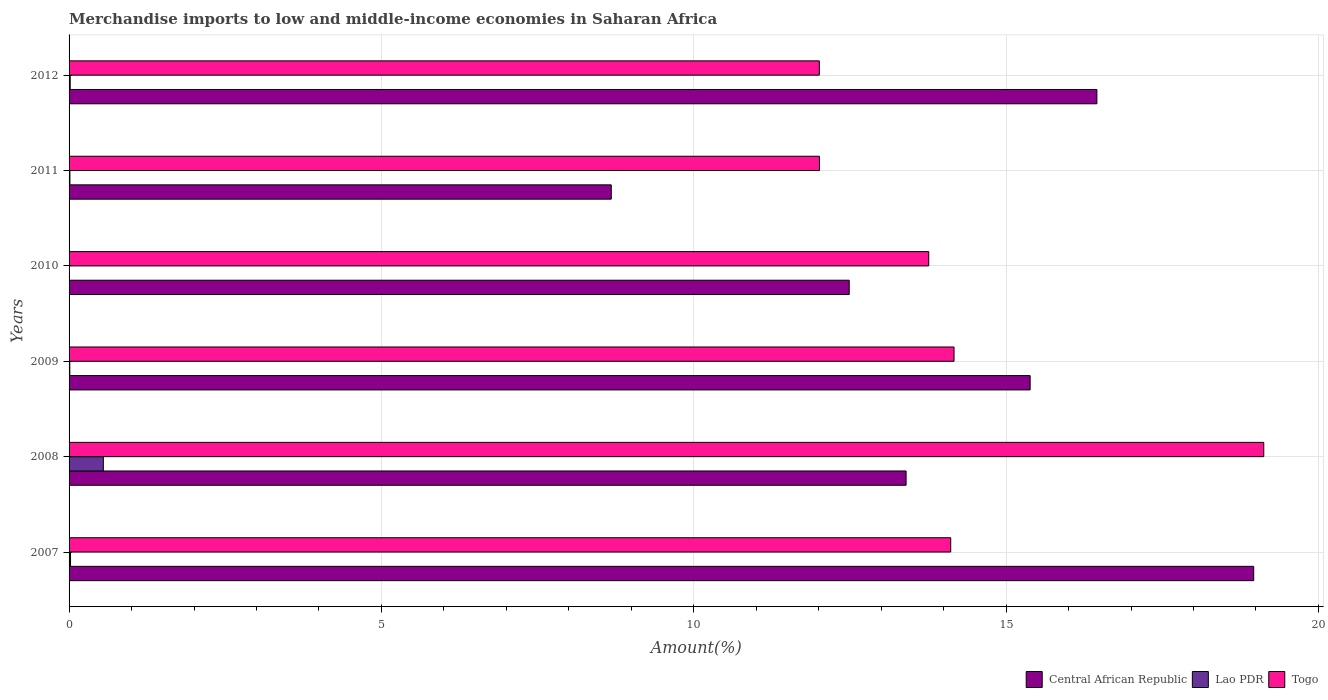Are the number of bars per tick equal to the number of legend labels?
Make the answer very short. Yes. Are the number of bars on each tick of the Y-axis equal?
Your answer should be very brief. Yes. In how many cases, is the number of bars for a given year not equal to the number of legend labels?
Provide a short and direct response. 0. What is the percentage of amount earned from merchandise imports in Central African Republic in 2012?
Make the answer very short. 16.45. Across all years, what is the maximum percentage of amount earned from merchandise imports in Lao PDR?
Offer a terse response. 0.55. Across all years, what is the minimum percentage of amount earned from merchandise imports in Central African Republic?
Your answer should be compact. 8.68. In which year was the percentage of amount earned from merchandise imports in Togo minimum?
Provide a succinct answer. 2012. What is the total percentage of amount earned from merchandise imports in Togo in the graph?
Ensure brevity in your answer.  85.19. What is the difference between the percentage of amount earned from merchandise imports in Lao PDR in 2008 and that in 2009?
Make the answer very short. 0.54. What is the difference between the percentage of amount earned from merchandise imports in Central African Republic in 2008 and the percentage of amount earned from merchandise imports in Lao PDR in 2012?
Ensure brevity in your answer.  13.38. What is the average percentage of amount earned from merchandise imports in Togo per year?
Keep it short and to the point. 14.2. In the year 2007, what is the difference between the percentage of amount earned from merchandise imports in Central African Republic and percentage of amount earned from merchandise imports in Togo?
Give a very brief answer. 4.85. What is the ratio of the percentage of amount earned from merchandise imports in Lao PDR in 2009 to that in 2010?
Ensure brevity in your answer.  2.69. Is the percentage of amount earned from merchandise imports in Lao PDR in 2010 less than that in 2011?
Keep it short and to the point. Yes. What is the difference between the highest and the second highest percentage of amount earned from merchandise imports in Lao PDR?
Ensure brevity in your answer.  0.53. What is the difference between the highest and the lowest percentage of amount earned from merchandise imports in Lao PDR?
Your answer should be compact. 0.54. What does the 3rd bar from the top in 2009 represents?
Your answer should be very brief. Central African Republic. What does the 3rd bar from the bottom in 2012 represents?
Provide a succinct answer. Togo. Is it the case that in every year, the sum of the percentage of amount earned from merchandise imports in Lao PDR and percentage of amount earned from merchandise imports in Togo is greater than the percentage of amount earned from merchandise imports in Central African Republic?
Your answer should be very brief. No. How many bars are there?
Your answer should be compact. 18. Are all the bars in the graph horizontal?
Provide a short and direct response. Yes. What is the difference between two consecutive major ticks on the X-axis?
Your answer should be compact. 5. Does the graph contain any zero values?
Your response must be concise. No. Does the graph contain grids?
Ensure brevity in your answer.  Yes. What is the title of the graph?
Keep it short and to the point. Merchandise imports to low and middle-income economies in Saharan Africa. What is the label or title of the X-axis?
Ensure brevity in your answer.  Amount(%). What is the label or title of the Y-axis?
Provide a succinct answer. Years. What is the Amount(%) of Central African Republic in 2007?
Make the answer very short. 18.96. What is the Amount(%) in Lao PDR in 2007?
Ensure brevity in your answer.  0.02. What is the Amount(%) of Togo in 2007?
Your response must be concise. 14.11. What is the Amount(%) in Central African Republic in 2008?
Make the answer very short. 13.4. What is the Amount(%) in Lao PDR in 2008?
Your answer should be compact. 0.55. What is the Amount(%) in Togo in 2008?
Provide a short and direct response. 19.12. What is the Amount(%) in Central African Republic in 2009?
Keep it short and to the point. 15.39. What is the Amount(%) of Lao PDR in 2009?
Offer a terse response. 0.01. What is the Amount(%) of Togo in 2009?
Offer a terse response. 14.17. What is the Amount(%) of Central African Republic in 2010?
Make the answer very short. 12.49. What is the Amount(%) of Lao PDR in 2010?
Provide a succinct answer. 0. What is the Amount(%) in Togo in 2010?
Give a very brief answer. 13.76. What is the Amount(%) in Central African Republic in 2011?
Keep it short and to the point. 8.68. What is the Amount(%) of Lao PDR in 2011?
Your answer should be compact. 0.01. What is the Amount(%) of Togo in 2011?
Offer a terse response. 12.01. What is the Amount(%) in Central African Republic in 2012?
Your answer should be very brief. 16.45. What is the Amount(%) of Lao PDR in 2012?
Give a very brief answer. 0.02. What is the Amount(%) of Togo in 2012?
Offer a terse response. 12.01. Across all years, what is the maximum Amount(%) of Central African Republic?
Ensure brevity in your answer.  18.96. Across all years, what is the maximum Amount(%) of Lao PDR?
Provide a succinct answer. 0.55. Across all years, what is the maximum Amount(%) of Togo?
Your answer should be very brief. 19.12. Across all years, what is the minimum Amount(%) in Central African Republic?
Provide a short and direct response. 8.68. Across all years, what is the minimum Amount(%) of Lao PDR?
Provide a short and direct response. 0. Across all years, what is the minimum Amount(%) of Togo?
Ensure brevity in your answer.  12.01. What is the total Amount(%) in Central African Republic in the graph?
Provide a short and direct response. 85.37. What is the total Amount(%) of Lao PDR in the graph?
Your answer should be very brief. 0.62. What is the total Amount(%) of Togo in the graph?
Offer a terse response. 85.19. What is the difference between the Amount(%) of Central African Republic in 2007 and that in 2008?
Your answer should be compact. 5.57. What is the difference between the Amount(%) in Lao PDR in 2007 and that in 2008?
Provide a succinct answer. -0.53. What is the difference between the Amount(%) of Togo in 2007 and that in 2008?
Give a very brief answer. -5.01. What is the difference between the Amount(%) of Central African Republic in 2007 and that in 2009?
Provide a succinct answer. 3.58. What is the difference between the Amount(%) of Lao PDR in 2007 and that in 2009?
Give a very brief answer. 0.01. What is the difference between the Amount(%) in Togo in 2007 and that in 2009?
Provide a succinct answer. -0.05. What is the difference between the Amount(%) of Central African Republic in 2007 and that in 2010?
Provide a succinct answer. 6.48. What is the difference between the Amount(%) of Lao PDR in 2007 and that in 2010?
Ensure brevity in your answer.  0.02. What is the difference between the Amount(%) of Togo in 2007 and that in 2010?
Give a very brief answer. 0.35. What is the difference between the Amount(%) in Central African Republic in 2007 and that in 2011?
Give a very brief answer. 10.28. What is the difference between the Amount(%) of Lao PDR in 2007 and that in 2011?
Your response must be concise. 0.01. What is the difference between the Amount(%) of Togo in 2007 and that in 2011?
Provide a succinct answer. 2.1. What is the difference between the Amount(%) of Central African Republic in 2007 and that in 2012?
Provide a succinct answer. 2.51. What is the difference between the Amount(%) in Lao PDR in 2007 and that in 2012?
Provide a short and direct response. 0.01. What is the difference between the Amount(%) of Togo in 2007 and that in 2012?
Offer a very short reply. 2.1. What is the difference between the Amount(%) in Central African Republic in 2008 and that in 2009?
Keep it short and to the point. -1.99. What is the difference between the Amount(%) of Lao PDR in 2008 and that in 2009?
Your response must be concise. 0.54. What is the difference between the Amount(%) in Togo in 2008 and that in 2009?
Make the answer very short. 4.96. What is the difference between the Amount(%) in Central African Republic in 2008 and that in 2010?
Keep it short and to the point. 0.91. What is the difference between the Amount(%) in Lao PDR in 2008 and that in 2010?
Ensure brevity in your answer.  0.54. What is the difference between the Amount(%) of Togo in 2008 and that in 2010?
Your response must be concise. 5.36. What is the difference between the Amount(%) in Central African Republic in 2008 and that in 2011?
Keep it short and to the point. 4.72. What is the difference between the Amount(%) in Lao PDR in 2008 and that in 2011?
Give a very brief answer. 0.53. What is the difference between the Amount(%) of Togo in 2008 and that in 2011?
Provide a short and direct response. 7.11. What is the difference between the Amount(%) in Central African Republic in 2008 and that in 2012?
Provide a succinct answer. -3.05. What is the difference between the Amount(%) of Lao PDR in 2008 and that in 2012?
Provide a short and direct response. 0.53. What is the difference between the Amount(%) of Togo in 2008 and that in 2012?
Make the answer very short. 7.11. What is the difference between the Amount(%) in Central African Republic in 2009 and that in 2010?
Keep it short and to the point. 2.9. What is the difference between the Amount(%) of Lao PDR in 2009 and that in 2010?
Offer a very short reply. 0.01. What is the difference between the Amount(%) in Togo in 2009 and that in 2010?
Ensure brevity in your answer.  0.41. What is the difference between the Amount(%) in Central African Republic in 2009 and that in 2011?
Offer a terse response. 6.71. What is the difference between the Amount(%) in Lao PDR in 2009 and that in 2011?
Provide a succinct answer. -0. What is the difference between the Amount(%) in Togo in 2009 and that in 2011?
Ensure brevity in your answer.  2.15. What is the difference between the Amount(%) of Central African Republic in 2009 and that in 2012?
Keep it short and to the point. -1.07. What is the difference between the Amount(%) of Lao PDR in 2009 and that in 2012?
Ensure brevity in your answer.  -0.01. What is the difference between the Amount(%) in Togo in 2009 and that in 2012?
Give a very brief answer. 2.16. What is the difference between the Amount(%) of Central African Republic in 2010 and that in 2011?
Provide a short and direct response. 3.81. What is the difference between the Amount(%) of Lao PDR in 2010 and that in 2011?
Your response must be concise. -0.01. What is the difference between the Amount(%) in Togo in 2010 and that in 2011?
Your answer should be compact. 1.75. What is the difference between the Amount(%) of Central African Republic in 2010 and that in 2012?
Offer a very short reply. -3.96. What is the difference between the Amount(%) in Lao PDR in 2010 and that in 2012?
Offer a terse response. -0.01. What is the difference between the Amount(%) of Togo in 2010 and that in 2012?
Provide a succinct answer. 1.75. What is the difference between the Amount(%) of Central African Republic in 2011 and that in 2012?
Provide a succinct answer. -7.77. What is the difference between the Amount(%) in Lao PDR in 2011 and that in 2012?
Your answer should be compact. -0. What is the difference between the Amount(%) of Togo in 2011 and that in 2012?
Your response must be concise. 0. What is the difference between the Amount(%) of Central African Republic in 2007 and the Amount(%) of Lao PDR in 2008?
Offer a very short reply. 18.42. What is the difference between the Amount(%) of Central African Republic in 2007 and the Amount(%) of Togo in 2008?
Offer a very short reply. -0.16. What is the difference between the Amount(%) in Lao PDR in 2007 and the Amount(%) in Togo in 2008?
Your answer should be compact. -19.1. What is the difference between the Amount(%) of Central African Republic in 2007 and the Amount(%) of Lao PDR in 2009?
Your answer should be compact. 18.95. What is the difference between the Amount(%) in Central African Republic in 2007 and the Amount(%) in Togo in 2009?
Provide a short and direct response. 4.8. What is the difference between the Amount(%) in Lao PDR in 2007 and the Amount(%) in Togo in 2009?
Your response must be concise. -14.14. What is the difference between the Amount(%) in Central African Republic in 2007 and the Amount(%) in Lao PDR in 2010?
Your response must be concise. 18.96. What is the difference between the Amount(%) in Central African Republic in 2007 and the Amount(%) in Togo in 2010?
Offer a very short reply. 5.2. What is the difference between the Amount(%) in Lao PDR in 2007 and the Amount(%) in Togo in 2010?
Ensure brevity in your answer.  -13.74. What is the difference between the Amount(%) in Central African Republic in 2007 and the Amount(%) in Lao PDR in 2011?
Offer a terse response. 18.95. What is the difference between the Amount(%) of Central African Republic in 2007 and the Amount(%) of Togo in 2011?
Ensure brevity in your answer.  6.95. What is the difference between the Amount(%) in Lao PDR in 2007 and the Amount(%) in Togo in 2011?
Your answer should be very brief. -11.99. What is the difference between the Amount(%) in Central African Republic in 2007 and the Amount(%) in Lao PDR in 2012?
Provide a short and direct response. 18.95. What is the difference between the Amount(%) of Central African Republic in 2007 and the Amount(%) of Togo in 2012?
Make the answer very short. 6.95. What is the difference between the Amount(%) in Lao PDR in 2007 and the Amount(%) in Togo in 2012?
Offer a terse response. -11.99. What is the difference between the Amount(%) in Central African Republic in 2008 and the Amount(%) in Lao PDR in 2009?
Provide a short and direct response. 13.39. What is the difference between the Amount(%) in Central African Republic in 2008 and the Amount(%) in Togo in 2009?
Keep it short and to the point. -0.77. What is the difference between the Amount(%) in Lao PDR in 2008 and the Amount(%) in Togo in 2009?
Offer a terse response. -13.62. What is the difference between the Amount(%) of Central African Republic in 2008 and the Amount(%) of Lao PDR in 2010?
Provide a succinct answer. 13.39. What is the difference between the Amount(%) of Central African Republic in 2008 and the Amount(%) of Togo in 2010?
Provide a short and direct response. -0.36. What is the difference between the Amount(%) of Lao PDR in 2008 and the Amount(%) of Togo in 2010?
Keep it short and to the point. -13.21. What is the difference between the Amount(%) of Central African Republic in 2008 and the Amount(%) of Lao PDR in 2011?
Make the answer very short. 13.39. What is the difference between the Amount(%) in Central African Republic in 2008 and the Amount(%) in Togo in 2011?
Your answer should be compact. 1.39. What is the difference between the Amount(%) in Lao PDR in 2008 and the Amount(%) in Togo in 2011?
Provide a succinct answer. -11.46. What is the difference between the Amount(%) in Central African Republic in 2008 and the Amount(%) in Lao PDR in 2012?
Provide a succinct answer. 13.38. What is the difference between the Amount(%) in Central African Republic in 2008 and the Amount(%) in Togo in 2012?
Your response must be concise. 1.39. What is the difference between the Amount(%) of Lao PDR in 2008 and the Amount(%) of Togo in 2012?
Provide a short and direct response. -11.46. What is the difference between the Amount(%) in Central African Republic in 2009 and the Amount(%) in Lao PDR in 2010?
Provide a short and direct response. 15.38. What is the difference between the Amount(%) of Central African Republic in 2009 and the Amount(%) of Togo in 2010?
Your answer should be compact. 1.62. What is the difference between the Amount(%) in Lao PDR in 2009 and the Amount(%) in Togo in 2010?
Provide a succinct answer. -13.75. What is the difference between the Amount(%) in Central African Republic in 2009 and the Amount(%) in Lao PDR in 2011?
Your response must be concise. 15.37. What is the difference between the Amount(%) of Central African Republic in 2009 and the Amount(%) of Togo in 2011?
Keep it short and to the point. 3.37. What is the difference between the Amount(%) of Lao PDR in 2009 and the Amount(%) of Togo in 2011?
Ensure brevity in your answer.  -12. What is the difference between the Amount(%) in Central African Republic in 2009 and the Amount(%) in Lao PDR in 2012?
Keep it short and to the point. 15.37. What is the difference between the Amount(%) of Central African Republic in 2009 and the Amount(%) of Togo in 2012?
Your answer should be very brief. 3.37. What is the difference between the Amount(%) in Lao PDR in 2009 and the Amount(%) in Togo in 2012?
Make the answer very short. -12. What is the difference between the Amount(%) in Central African Republic in 2010 and the Amount(%) in Lao PDR in 2011?
Offer a very short reply. 12.48. What is the difference between the Amount(%) of Central African Republic in 2010 and the Amount(%) of Togo in 2011?
Keep it short and to the point. 0.48. What is the difference between the Amount(%) in Lao PDR in 2010 and the Amount(%) in Togo in 2011?
Ensure brevity in your answer.  -12.01. What is the difference between the Amount(%) of Central African Republic in 2010 and the Amount(%) of Lao PDR in 2012?
Provide a short and direct response. 12.47. What is the difference between the Amount(%) in Central African Republic in 2010 and the Amount(%) in Togo in 2012?
Your answer should be compact. 0.48. What is the difference between the Amount(%) in Lao PDR in 2010 and the Amount(%) in Togo in 2012?
Your answer should be very brief. -12.01. What is the difference between the Amount(%) in Central African Republic in 2011 and the Amount(%) in Lao PDR in 2012?
Ensure brevity in your answer.  8.66. What is the difference between the Amount(%) of Central African Republic in 2011 and the Amount(%) of Togo in 2012?
Provide a short and direct response. -3.33. What is the difference between the Amount(%) of Lao PDR in 2011 and the Amount(%) of Togo in 2012?
Offer a very short reply. -12. What is the average Amount(%) of Central African Republic per year?
Make the answer very short. 14.23. What is the average Amount(%) of Lao PDR per year?
Offer a terse response. 0.1. What is the average Amount(%) of Togo per year?
Your response must be concise. 14.2. In the year 2007, what is the difference between the Amount(%) in Central African Republic and Amount(%) in Lao PDR?
Give a very brief answer. 18.94. In the year 2007, what is the difference between the Amount(%) of Central African Republic and Amount(%) of Togo?
Your answer should be very brief. 4.85. In the year 2007, what is the difference between the Amount(%) of Lao PDR and Amount(%) of Togo?
Offer a terse response. -14.09. In the year 2008, what is the difference between the Amount(%) in Central African Republic and Amount(%) in Lao PDR?
Your answer should be compact. 12.85. In the year 2008, what is the difference between the Amount(%) of Central African Republic and Amount(%) of Togo?
Give a very brief answer. -5.73. In the year 2008, what is the difference between the Amount(%) of Lao PDR and Amount(%) of Togo?
Ensure brevity in your answer.  -18.58. In the year 2009, what is the difference between the Amount(%) of Central African Republic and Amount(%) of Lao PDR?
Offer a very short reply. 15.37. In the year 2009, what is the difference between the Amount(%) in Central African Republic and Amount(%) in Togo?
Your answer should be compact. 1.22. In the year 2009, what is the difference between the Amount(%) in Lao PDR and Amount(%) in Togo?
Your answer should be compact. -14.15. In the year 2010, what is the difference between the Amount(%) in Central African Republic and Amount(%) in Lao PDR?
Your answer should be very brief. 12.48. In the year 2010, what is the difference between the Amount(%) in Central African Republic and Amount(%) in Togo?
Your answer should be very brief. -1.27. In the year 2010, what is the difference between the Amount(%) in Lao PDR and Amount(%) in Togo?
Give a very brief answer. -13.76. In the year 2011, what is the difference between the Amount(%) in Central African Republic and Amount(%) in Lao PDR?
Your answer should be compact. 8.67. In the year 2011, what is the difference between the Amount(%) in Central African Republic and Amount(%) in Togo?
Ensure brevity in your answer.  -3.33. In the year 2011, what is the difference between the Amount(%) of Lao PDR and Amount(%) of Togo?
Provide a succinct answer. -12. In the year 2012, what is the difference between the Amount(%) in Central African Republic and Amount(%) in Lao PDR?
Your response must be concise. 16.44. In the year 2012, what is the difference between the Amount(%) of Central African Republic and Amount(%) of Togo?
Your response must be concise. 4.44. In the year 2012, what is the difference between the Amount(%) in Lao PDR and Amount(%) in Togo?
Ensure brevity in your answer.  -11.99. What is the ratio of the Amount(%) in Central African Republic in 2007 to that in 2008?
Your answer should be compact. 1.42. What is the ratio of the Amount(%) of Lao PDR in 2007 to that in 2008?
Provide a short and direct response. 0.04. What is the ratio of the Amount(%) of Togo in 2007 to that in 2008?
Provide a short and direct response. 0.74. What is the ratio of the Amount(%) in Central African Republic in 2007 to that in 2009?
Make the answer very short. 1.23. What is the ratio of the Amount(%) in Lao PDR in 2007 to that in 2009?
Provide a succinct answer. 1.99. What is the ratio of the Amount(%) in Togo in 2007 to that in 2009?
Provide a short and direct response. 1. What is the ratio of the Amount(%) in Central African Republic in 2007 to that in 2010?
Offer a very short reply. 1.52. What is the ratio of the Amount(%) of Lao PDR in 2007 to that in 2010?
Keep it short and to the point. 5.36. What is the ratio of the Amount(%) in Togo in 2007 to that in 2010?
Provide a succinct answer. 1.03. What is the ratio of the Amount(%) in Central African Republic in 2007 to that in 2011?
Ensure brevity in your answer.  2.18. What is the ratio of the Amount(%) of Lao PDR in 2007 to that in 2011?
Your answer should be very brief. 1.69. What is the ratio of the Amount(%) in Togo in 2007 to that in 2011?
Give a very brief answer. 1.18. What is the ratio of the Amount(%) in Central African Republic in 2007 to that in 2012?
Offer a very short reply. 1.15. What is the ratio of the Amount(%) of Lao PDR in 2007 to that in 2012?
Make the answer very short. 1.29. What is the ratio of the Amount(%) of Togo in 2007 to that in 2012?
Give a very brief answer. 1.18. What is the ratio of the Amount(%) in Central African Republic in 2008 to that in 2009?
Your answer should be compact. 0.87. What is the ratio of the Amount(%) in Lao PDR in 2008 to that in 2009?
Provide a short and direct response. 47.05. What is the ratio of the Amount(%) in Togo in 2008 to that in 2009?
Keep it short and to the point. 1.35. What is the ratio of the Amount(%) of Central African Republic in 2008 to that in 2010?
Ensure brevity in your answer.  1.07. What is the ratio of the Amount(%) in Lao PDR in 2008 to that in 2010?
Give a very brief answer. 126.71. What is the ratio of the Amount(%) of Togo in 2008 to that in 2010?
Ensure brevity in your answer.  1.39. What is the ratio of the Amount(%) of Central African Republic in 2008 to that in 2011?
Make the answer very short. 1.54. What is the ratio of the Amount(%) in Lao PDR in 2008 to that in 2011?
Ensure brevity in your answer.  40.03. What is the ratio of the Amount(%) of Togo in 2008 to that in 2011?
Ensure brevity in your answer.  1.59. What is the ratio of the Amount(%) in Central African Republic in 2008 to that in 2012?
Give a very brief answer. 0.81. What is the ratio of the Amount(%) in Lao PDR in 2008 to that in 2012?
Offer a terse response. 30.54. What is the ratio of the Amount(%) of Togo in 2008 to that in 2012?
Offer a terse response. 1.59. What is the ratio of the Amount(%) of Central African Republic in 2009 to that in 2010?
Offer a very short reply. 1.23. What is the ratio of the Amount(%) of Lao PDR in 2009 to that in 2010?
Your answer should be very brief. 2.69. What is the ratio of the Amount(%) in Togo in 2009 to that in 2010?
Your answer should be very brief. 1.03. What is the ratio of the Amount(%) in Central African Republic in 2009 to that in 2011?
Your answer should be very brief. 1.77. What is the ratio of the Amount(%) of Lao PDR in 2009 to that in 2011?
Give a very brief answer. 0.85. What is the ratio of the Amount(%) of Togo in 2009 to that in 2011?
Provide a succinct answer. 1.18. What is the ratio of the Amount(%) in Central African Republic in 2009 to that in 2012?
Keep it short and to the point. 0.94. What is the ratio of the Amount(%) of Lao PDR in 2009 to that in 2012?
Keep it short and to the point. 0.65. What is the ratio of the Amount(%) of Togo in 2009 to that in 2012?
Provide a succinct answer. 1.18. What is the ratio of the Amount(%) of Central African Republic in 2010 to that in 2011?
Make the answer very short. 1.44. What is the ratio of the Amount(%) of Lao PDR in 2010 to that in 2011?
Offer a very short reply. 0.32. What is the ratio of the Amount(%) of Togo in 2010 to that in 2011?
Make the answer very short. 1.15. What is the ratio of the Amount(%) of Central African Republic in 2010 to that in 2012?
Give a very brief answer. 0.76. What is the ratio of the Amount(%) of Lao PDR in 2010 to that in 2012?
Ensure brevity in your answer.  0.24. What is the ratio of the Amount(%) in Togo in 2010 to that in 2012?
Provide a short and direct response. 1.15. What is the ratio of the Amount(%) of Central African Republic in 2011 to that in 2012?
Provide a short and direct response. 0.53. What is the ratio of the Amount(%) in Lao PDR in 2011 to that in 2012?
Provide a short and direct response. 0.76. What is the difference between the highest and the second highest Amount(%) of Central African Republic?
Your answer should be very brief. 2.51. What is the difference between the highest and the second highest Amount(%) of Lao PDR?
Make the answer very short. 0.53. What is the difference between the highest and the second highest Amount(%) of Togo?
Your response must be concise. 4.96. What is the difference between the highest and the lowest Amount(%) in Central African Republic?
Offer a terse response. 10.28. What is the difference between the highest and the lowest Amount(%) in Lao PDR?
Keep it short and to the point. 0.54. What is the difference between the highest and the lowest Amount(%) in Togo?
Keep it short and to the point. 7.11. 